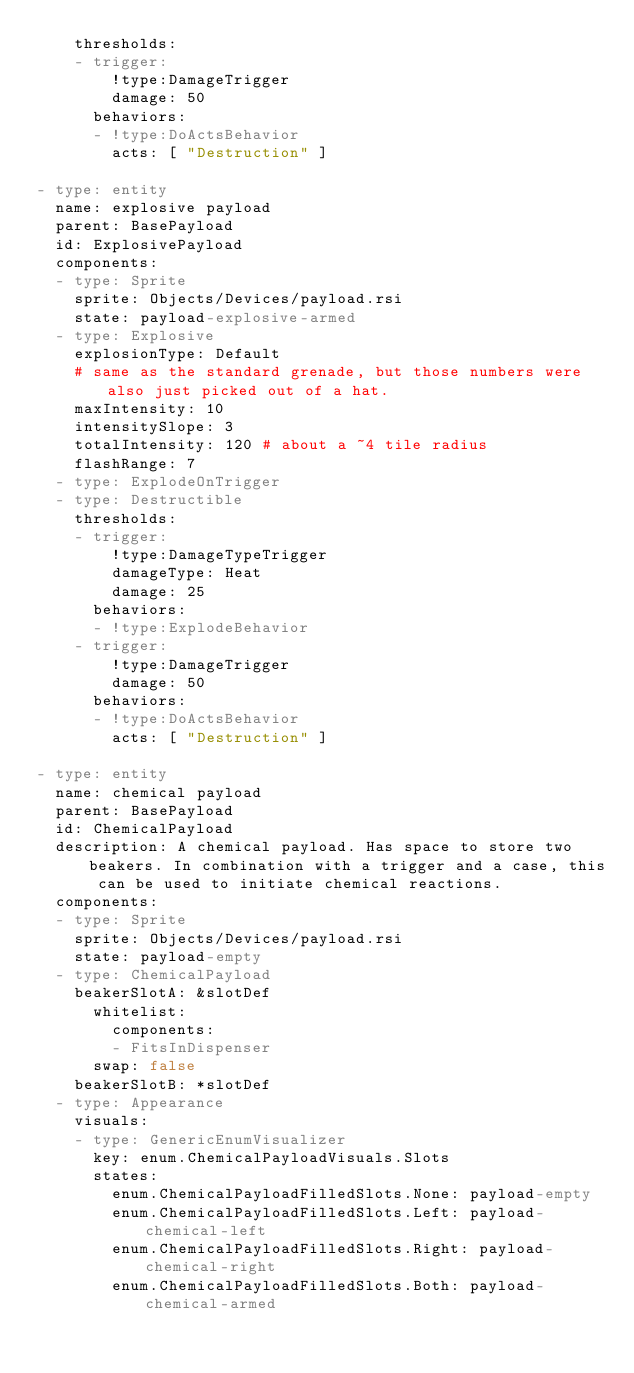<code> <loc_0><loc_0><loc_500><loc_500><_YAML_>    thresholds:
    - trigger:
        !type:DamageTrigger
        damage: 50
      behaviors:
      - !type:DoActsBehavior
        acts: [ "Destruction" ]

- type: entity
  name: explosive payload
  parent: BasePayload
  id: ExplosivePayload
  components:
  - type: Sprite
    sprite: Objects/Devices/payload.rsi
    state: payload-explosive-armed
  - type: Explosive
    explosionType: Default
    # same as the standard grenade, but those numbers were also just picked out of a hat.
    maxIntensity: 10
    intensitySlope: 3
    totalIntensity: 120 # about a ~4 tile radius
    flashRange: 7
  - type: ExplodeOnTrigger
  - type: Destructible
    thresholds:
    - trigger:
        !type:DamageTypeTrigger
        damageType: Heat
        damage: 25
      behaviors:
      - !type:ExplodeBehavior
    - trigger:
        !type:DamageTrigger
        damage: 50
      behaviors:
      - !type:DoActsBehavior
        acts: [ "Destruction" ]

- type: entity
  name: chemical payload
  parent: BasePayload
  id: ChemicalPayload
  description: A chemical payload. Has space to store two beakers. In combination with a trigger and a case, this can be used to initiate chemical reactions.
  components:
  - type: Sprite
    sprite: Objects/Devices/payload.rsi
    state: payload-empty
  - type: ChemicalPayload
    beakerSlotA: &slotDef
      whitelist:
        components:
        - FitsInDispenser
      swap: false
    beakerSlotB: *slotDef
  - type: Appearance
    visuals:
    - type: GenericEnumVisualizer
      key: enum.ChemicalPayloadVisuals.Slots
      states:
        enum.ChemicalPayloadFilledSlots.None: payload-empty
        enum.ChemicalPayloadFilledSlots.Left: payload-chemical-left
        enum.ChemicalPayloadFilledSlots.Right: payload-chemical-right
        enum.ChemicalPayloadFilledSlots.Both: payload-chemical-armed
</code> 